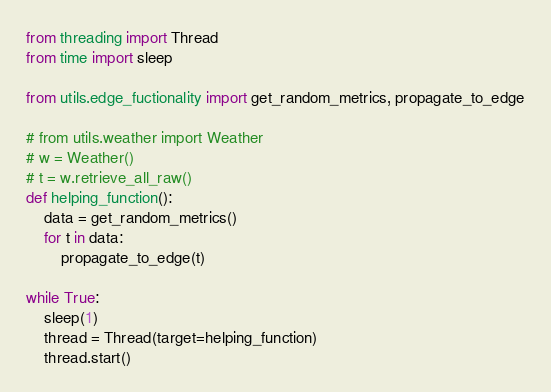Convert code to text. <code><loc_0><loc_0><loc_500><loc_500><_Python_>from threading import Thread
from time import sleep

from utils.edge_fuctionality import get_random_metrics, propagate_to_edge

# from utils.weather import Weather
# w = Weather()
# t = w.retrieve_all_raw()
def helping_function():
    data = get_random_metrics()
    for t in data:
        propagate_to_edge(t)

while True:
    sleep(1)
    thread = Thread(target=helping_function)
    thread.start()</code> 